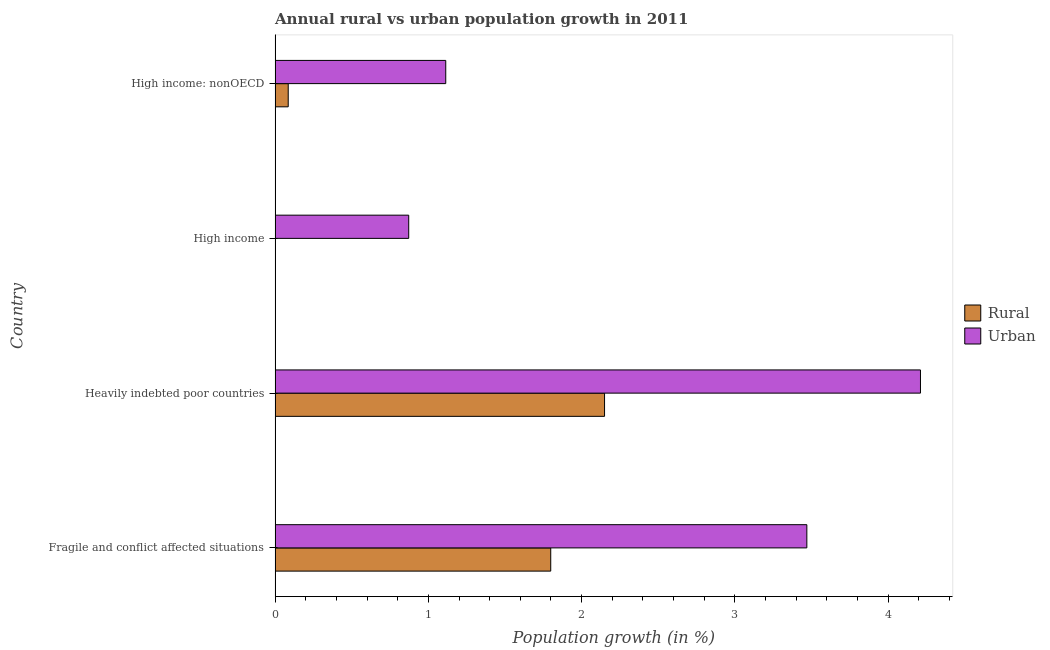How many different coloured bars are there?
Keep it short and to the point. 2. Are the number of bars per tick equal to the number of legend labels?
Keep it short and to the point. No. Are the number of bars on each tick of the Y-axis equal?
Your response must be concise. No. How many bars are there on the 1st tick from the bottom?
Make the answer very short. 2. What is the label of the 1st group of bars from the top?
Your answer should be very brief. High income: nonOECD. In how many cases, is the number of bars for a given country not equal to the number of legend labels?
Offer a terse response. 1. What is the urban population growth in Fragile and conflict affected situations?
Ensure brevity in your answer.  3.47. Across all countries, what is the maximum rural population growth?
Offer a very short reply. 2.15. Across all countries, what is the minimum urban population growth?
Ensure brevity in your answer.  0.87. In which country was the urban population growth maximum?
Your response must be concise. Heavily indebted poor countries. What is the total urban population growth in the graph?
Keep it short and to the point. 9.66. What is the difference between the urban population growth in Fragile and conflict affected situations and that in High income: nonOECD?
Give a very brief answer. 2.36. What is the difference between the rural population growth in High income and the urban population growth in Heavily indebted poor countries?
Your answer should be very brief. -4.21. What is the average rural population growth per country?
Provide a short and direct response. 1.01. What is the difference between the urban population growth and rural population growth in Heavily indebted poor countries?
Provide a succinct answer. 2.06. What is the ratio of the rural population growth in Heavily indebted poor countries to that in High income: nonOECD?
Your answer should be compact. 25.09. Is the difference between the urban population growth in Fragile and conflict affected situations and High income: nonOECD greater than the difference between the rural population growth in Fragile and conflict affected situations and High income: nonOECD?
Make the answer very short. Yes. What is the difference between the highest and the second highest urban population growth?
Offer a very short reply. 0.74. What is the difference between the highest and the lowest rural population growth?
Provide a short and direct response. 2.15. In how many countries, is the rural population growth greater than the average rural population growth taken over all countries?
Make the answer very short. 2. Is the sum of the urban population growth in Heavily indebted poor countries and High income greater than the maximum rural population growth across all countries?
Your answer should be very brief. Yes. Where does the legend appear in the graph?
Your response must be concise. Center right. How many legend labels are there?
Your answer should be very brief. 2. How are the legend labels stacked?
Your response must be concise. Vertical. What is the title of the graph?
Your answer should be compact. Annual rural vs urban population growth in 2011. What is the label or title of the X-axis?
Your answer should be compact. Population growth (in %). What is the Population growth (in %) in Rural in Fragile and conflict affected situations?
Your answer should be very brief. 1.8. What is the Population growth (in %) in Urban  in Fragile and conflict affected situations?
Ensure brevity in your answer.  3.47. What is the Population growth (in %) of Rural in Heavily indebted poor countries?
Ensure brevity in your answer.  2.15. What is the Population growth (in %) of Urban  in Heavily indebted poor countries?
Your response must be concise. 4.21. What is the Population growth (in %) in Rural in High income?
Provide a short and direct response. 0. What is the Population growth (in %) in Urban  in High income?
Ensure brevity in your answer.  0.87. What is the Population growth (in %) in Rural in High income: nonOECD?
Your answer should be compact. 0.09. What is the Population growth (in %) in Urban  in High income: nonOECD?
Offer a terse response. 1.11. Across all countries, what is the maximum Population growth (in %) in Rural?
Ensure brevity in your answer.  2.15. Across all countries, what is the maximum Population growth (in %) in Urban ?
Your answer should be very brief. 4.21. Across all countries, what is the minimum Population growth (in %) in Urban ?
Provide a succinct answer. 0.87. What is the total Population growth (in %) in Rural in the graph?
Keep it short and to the point. 4.03. What is the total Population growth (in %) of Urban  in the graph?
Offer a very short reply. 9.66. What is the difference between the Population growth (in %) of Rural in Fragile and conflict affected situations and that in Heavily indebted poor countries?
Your response must be concise. -0.35. What is the difference between the Population growth (in %) of Urban  in Fragile and conflict affected situations and that in Heavily indebted poor countries?
Provide a succinct answer. -0.74. What is the difference between the Population growth (in %) in Urban  in Fragile and conflict affected situations and that in High income?
Make the answer very short. 2.6. What is the difference between the Population growth (in %) of Rural in Fragile and conflict affected situations and that in High income: nonOECD?
Your answer should be very brief. 1.71. What is the difference between the Population growth (in %) of Urban  in Fragile and conflict affected situations and that in High income: nonOECD?
Make the answer very short. 2.36. What is the difference between the Population growth (in %) in Urban  in Heavily indebted poor countries and that in High income?
Provide a succinct answer. 3.34. What is the difference between the Population growth (in %) in Rural in Heavily indebted poor countries and that in High income: nonOECD?
Make the answer very short. 2.06. What is the difference between the Population growth (in %) in Urban  in Heavily indebted poor countries and that in High income: nonOECD?
Your answer should be very brief. 3.1. What is the difference between the Population growth (in %) of Urban  in High income and that in High income: nonOECD?
Give a very brief answer. -0.24. What is the difference between the Population growth (in %) of Rural in Fragile and conflict affected situations and the Population growth (in %) of Urban  in Heavily indebted poor countries?
Give a very brief answer. -2.41. What is the difference between the Population growth (in %) in Rural in Fragile and conflict affected situations and the Population growth (in %) in Urban  in High income?
Your response must be concise. 0.93. What is the difference between the Population growth (in %) of Rural in Fragile and conflict affected situations and the Population growth (in %) of Urban  in High income: nonOECD?
Offer a very short reply. 0.69. What is the difference between the Population growth (in %) in Rural in Heavily indebted poor countries and the Population growth (in %) in Urban  in High income?
Your answer should be compact. 1.28. What is the difference between the Population growth (in %) in Rural in Heavily indebted poor countries and the Population growth (in %) in Urban  in High income: nonOECD?
Provide a short and direct response. 1.04. What is the average Population growth (in %) in Rural per country?
Provide a succinct answer. 1.01. What is the average Population growth (in %) of Urban  per country?
Provide a succinct answer. 2.42. What is the difference between the Population growth (in %) in Rural and Population growth (in %) in Urban  in Fragile and conflict affected situations?
Your answer should be very brief. -1.67. What is the difference between the Population growth (in %) in Rural and Population growth (in %) in Urban  in Heavily indebted poor countries?
Ensure brevity in your answer.  -2.06. What is the difference between the Population growth (in %) in Rural and Population growth (in %) in Urban  in High income: nonOECD?
Your answer should be very brief. -1.03. What is the ratio of the Population growth (in %) of Rural in Fragile and conflict affected situations to that in Heavily indebted poor countries?
Ensure brevity in your answer.  0.84. What is the ratio of the Population growth (in %) of Urban  in Fragile and conflict affected situations to that in Heavily indebted poor countries?
Give a very brief answer. 0.82. What is the ratio of the Population growth (in %) of Urban  in Fragile and conflict affected situations to that in High income?
Give a very brief answer. 3.98. What is the ratio of the Population growth (in %) of Rural in Fragile and conflict affected situations to that in High income: nonOECD?
Keep it short and to the point. 20.99. What is the ratio of the Population growth (in %) of Urban  in Fragile and conflict affected situations to that in High income: nonOECD?
Offer a terse response. 3.12. What is the ratio of the Population growth (in %) in Urban  in Heavily indebted poor countries to that in High income?
Keep it short and to the point. 4.83. What is the ratio of the Population growth (in %) of Rural in Heavily indebted poor countries to that in High income: nonOECD?
Provide a succinct answer. 25.09. What is the ratio of the Population growth (in %) in Urban  in Heavily indebted poor countries to that in High income: nonOECD?
Provide a succinct answer. 3.78. What is the ratio of the Population growth (in %) in Urban  in High income to that in High income: nonOECD?
Make the answer very short. 0.78. What is the difference between the highest and the second highest Population growth (in %) in Rural?
Give a very brief answer. 0.35. What is the difference between the highest and the second highest Population growth (in %) of Urban ?
Your answer should be very brief. 0.74. What is the difference between the highest and the lowest Population growth (in %) in Rural?
Give a very brief answer. 2.15. What is the difference between the highest and the lowest Population growth (in %) in Urban ?
Make the answer very short. 3.34. 